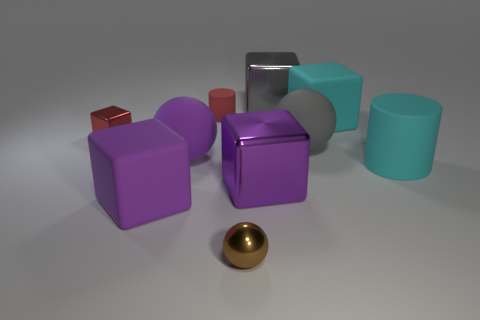Subtract all purple cylinders. How many purple blocks are left? 2 Subtract all tiny red shiny blocks. How many blocks are left? 4 Subtract all purple blocks. How many blocks are left? 3 Subtract 3 blocks. How many blocks are left? 2 Subtract all cylinders. How many objects are left? 8 Subtract all large purple rubber spheres. Subtract all rubber spheres. How many objects are left? 7 Add 7 small objects. How many small objects are left? 10 Add 2 cyan matte blocks. How many cyan matte blocks exist? 3 Subtract 1 purple cubes. How many objects are left? 9 Subtract all gray blocks. Subtract all blue spheres. How many blocks are left? 4 